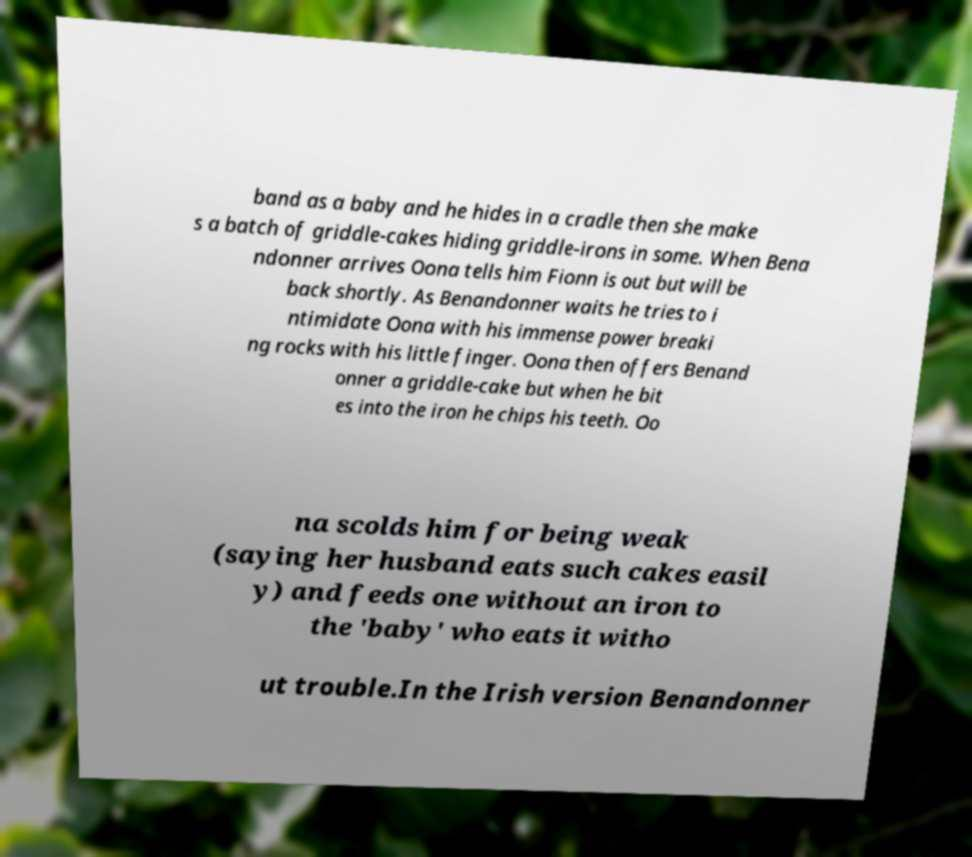Could you extract and type out the text from this image? band as a baby and he hides in a cradle then she make s a batch of griddle-cakes hiding griddle-irons in some. When Bena ndonner arrives Oona tells him Fionn is out but will be back shortly. As Benandonner waits he tries to i ntimidate Oona with his immense power breaki ng rocks with his little finger. Oona then offers Benand onner a griddle-cake but when he bit es into the iron he chips his teeth. Oo na scolds him for being weak (saying her husband eats such cakes easil y) and feeds one without an iron to the 'baby' who eats it witho ut trouble.In the Irish version Benandonner 